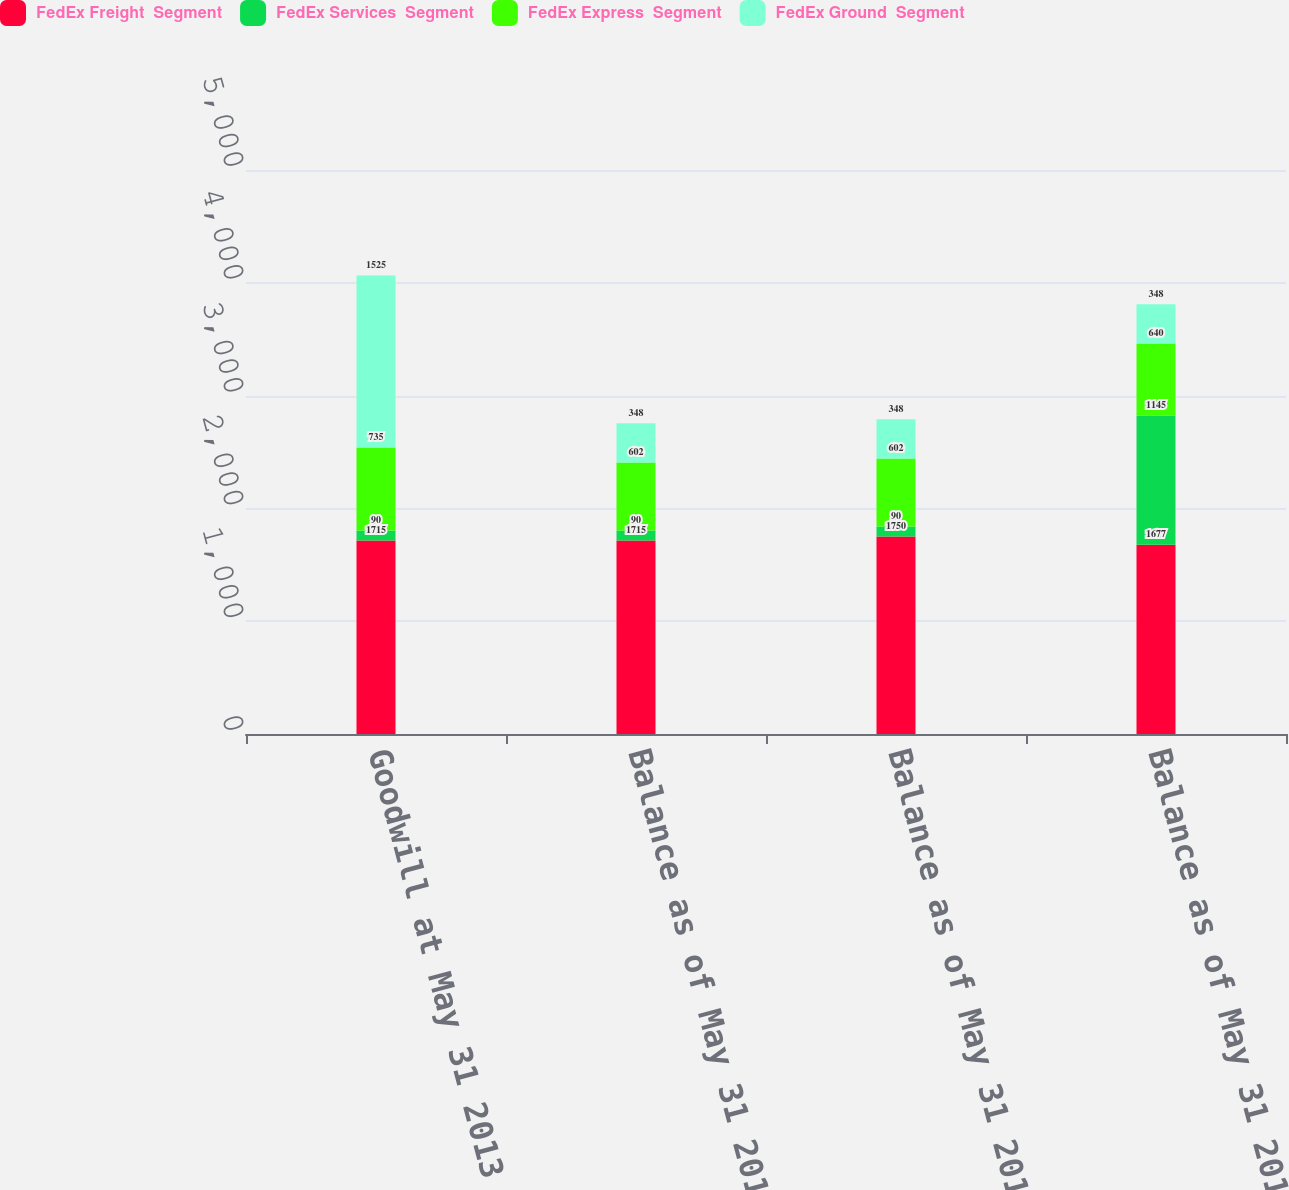<chart> <loc_0><loc_0><loc_500><loc_500><stacked_bar_chart><ecel><fcel>Goodwill at May 31 2013<fcel>Balance as of May 31 2013<fcel>Balance as of May 31 2014<fcel>Balance as of May 31 2015<nl><fcel>FedEx Freight  Segment<fcel>1715<fcel>1715<fcel>1750<fcel>1677<nl><fcel>FedEx Services  Segment<fcel>90<fcel>90<fcel>90<fcel>1145<nl><fcel>FedEx Express  Segment<fcel>735<fcel>602<fcel>602<fcel>640<nl><fcel>FedEx Ground  Segment<fcel>1525<fcel>348<fcel>348<fcel>348<nl></chart> 